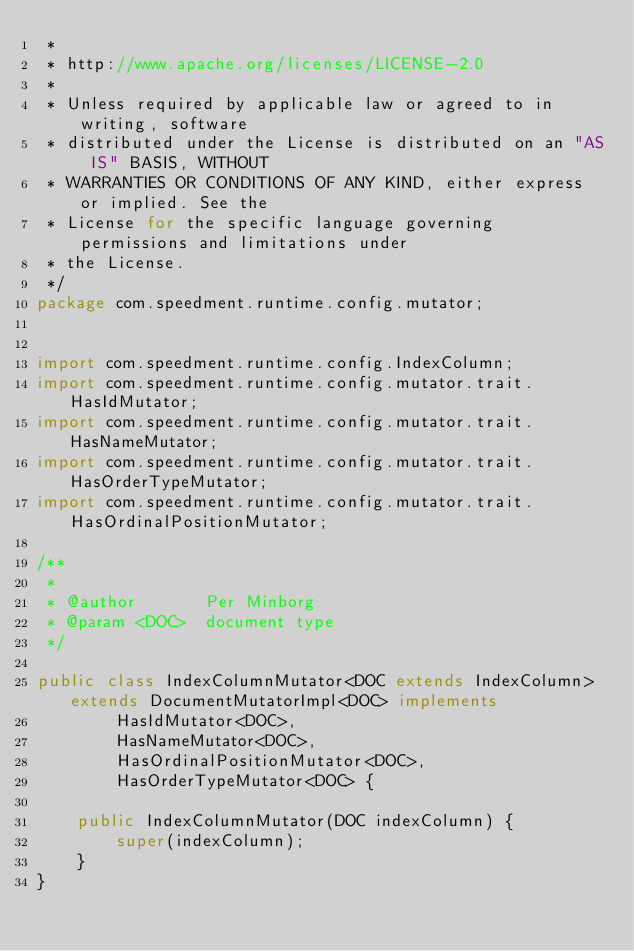<code> <loc_0><loc_0><loc_500><loc_500><_Java_> *
 * http://www.apache.org/licenses/LICENSE-2.0
 *
 * Unless required by applicable law or agreed to in writing, software
 * distributed under the License is distributed on an "AS IS" BASIS, WITHOUT
 * WARRANTIES OR CONDITIONS OF ANY KIND, either express or implied. See the
 * License for the specific language governing permissions and limitations under
 * the License.
 */
package com.speedment.runtime.config.mutator;


import com.speedment.runtime.config.IndexColumn;
import com.speedment.runtime.config.mutator.trait.HasIdMutator;
import com.speedment.runtime.config.mutator.trait.HasNameMutator;
import com.speedment.runtime.config.mutator.trait.HasOrderTypeMutator;
import com.speedment.runtime.config.mutator.trait.HasOrdinalPositionMutator;

/**
 *
 * @author       Per Minborg
 * @param <DOC>  document type
 */

public class IndexColumnMutator<DOC extends IndexColumn> extends DocumentMutatorImpl<DOC> implements 
        HasIdMutator<DOC>,    
        HasNameMutator<DOC>,
        HasOrdinalPositionMutator<DOC>, 
        HasOrderTypeMutator<DOC> {

    public IndexColumnMutator(DOC indexColumn) {
        super(indexColumn);
    }
}</code> 